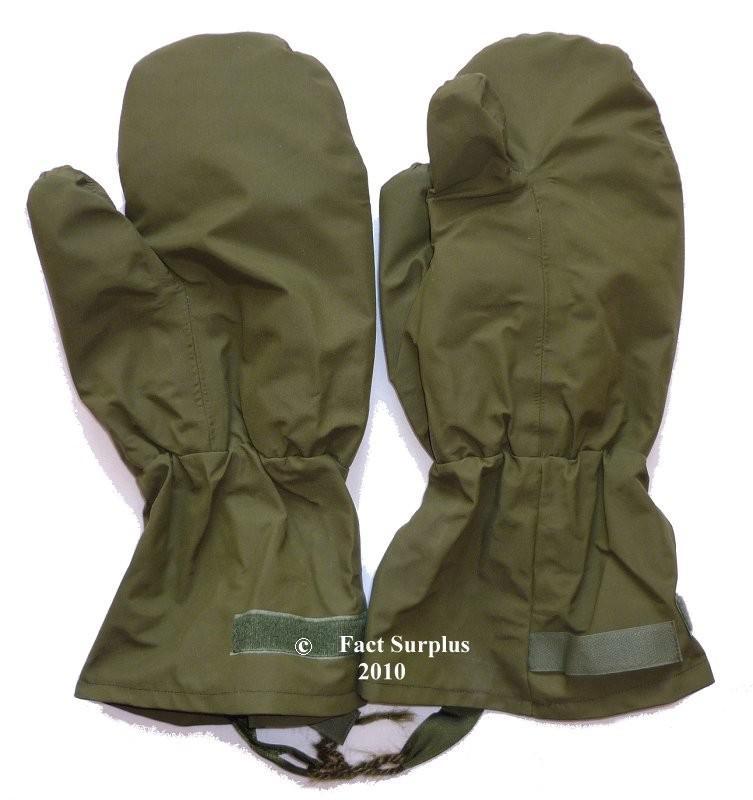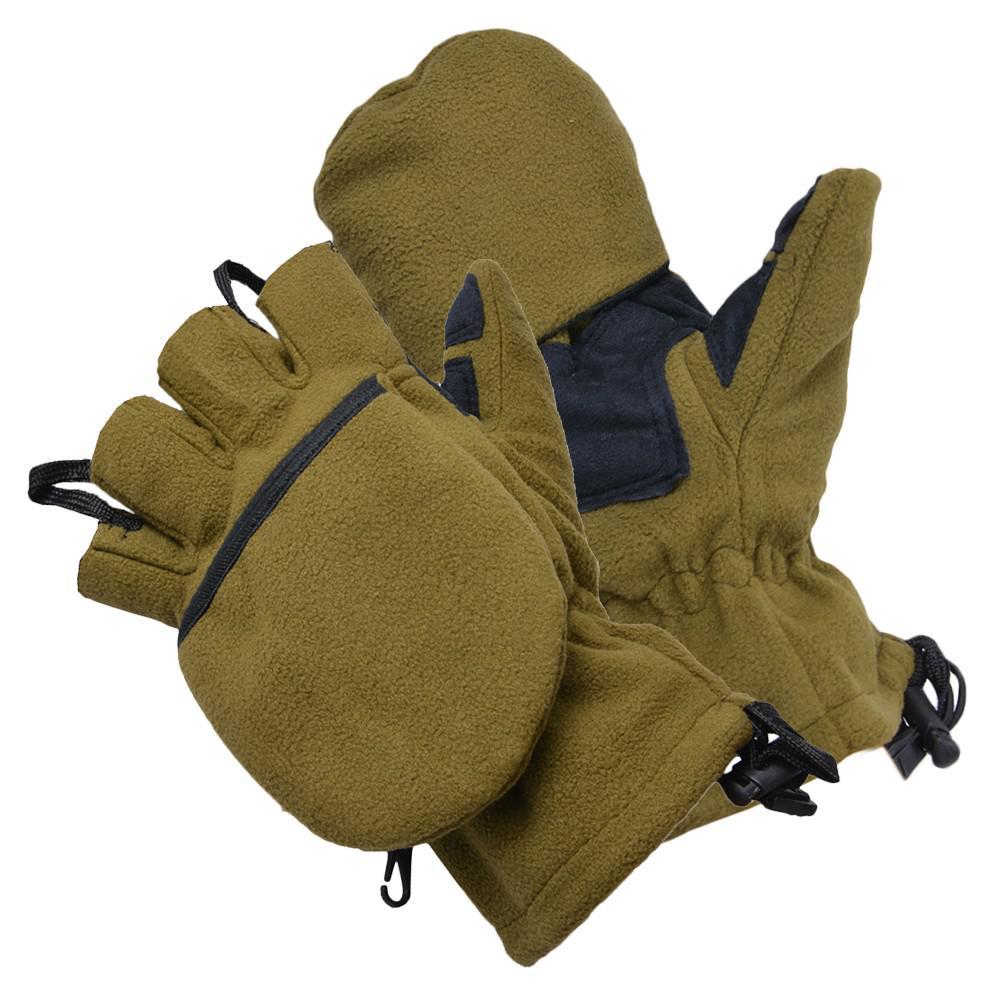The first image is the image on the left, the second image is the image on the right. Assess this claim about the two images: "Two of the gloves can be seen to have a woodland camouflage pattern.". Correct or not? Answer yes or no. No. The first image is the image on the left, the second image is the image on the right. Analyze the images presented: Is the assertion "One image shows a pair of mittens with half-fingers exposed on one mitt only." valid? Answer yes or no. Yes. 